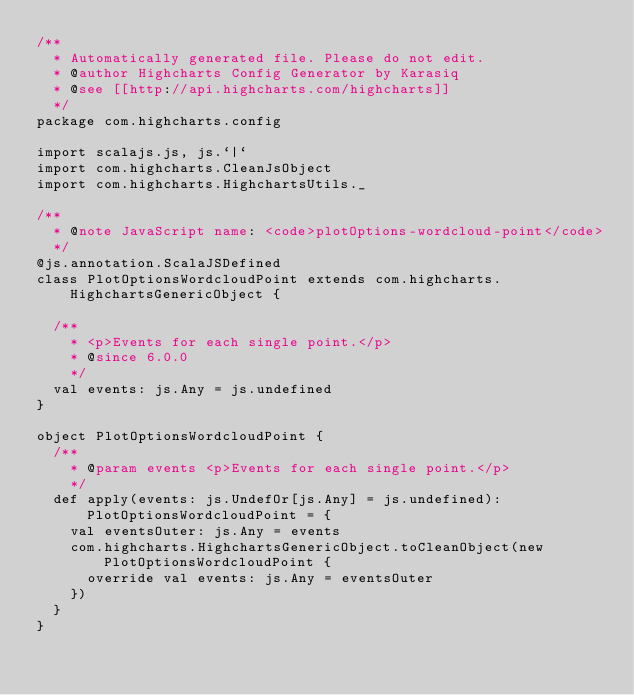<code> <loc_0><loc_0><loc_500><loc_500><_Scala_>/**
  * Automatically generated file. Please do not edit.
  * @author Highcharts Config Generator by Karasiq
  * @see [[http://api.highcharts.com/highcharts]]
  */
package com.highcharts.config

import scalajs.js, js.`|`
import com.highcharts.CleanJsObject
import com.highcharts.HighchartsUtils._

/**
  * @note JavaScript name: <code>plotOptions-wordcloud-point</code>
  */
@js.annotation.ScalaJSDefined
class PlotOptionsWordcloudPoint extends com.highcharts.HighchartsGenericObject {

  /**
    * <p>Events for each single point.</p>
    * @since 6.0.0
    */
  val events: js.Any = js.undefined
}

object PlotOptionsWordcloudPoint {
  /**
    * @param events <p>Events for each single point.</p>
    */
  def apply(events: js.UndefOr[js.Any] = js.undefined): PlotOptionsWordcloudPoint = {
    val eventsOuter: js.Any = events
    com.highcharts.HighchartsGenericObject.toCleanObject(new PlotOptionsWordcloudPoint {
      override val events: js.Any = eventsOuter
    })
  }
}
</code> 